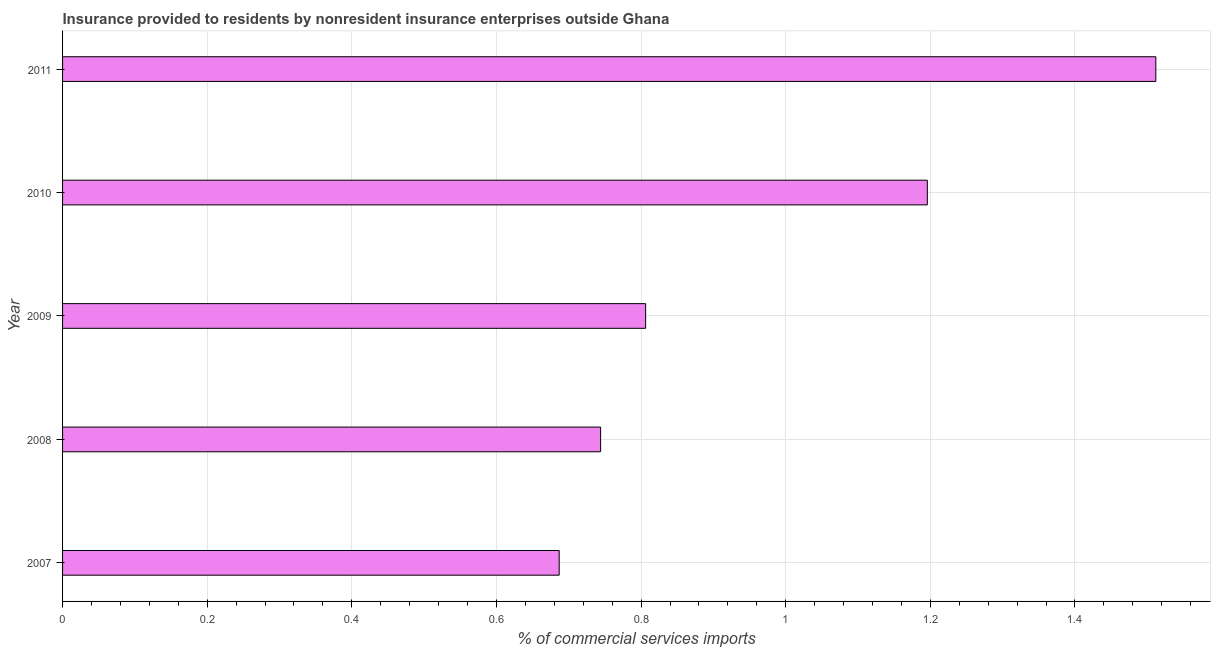Does the graph contain grids?
Offer a terse response. Yes. What is the title of the graph?
Provide a succinct answer. Insurance provided to residents by nonresident insurance enterprises outside Ghana. What is the label or title of the X-axis?
Give a very brief answer. % of commercial services imports. What is the insurance provided by non-residents in 2010?
Your answer should be very brief. 1.2. Across all years, what is the maximum insurance provided by non-residents?
Your answer should be very brief. 1.51. Across all years, what is the minimum insurance provided by non-residents?
Your answer should be very brief. 0.69. In which year was the insurance provided by non-residents maximum?
Offer a very short reply. 2011. What is the sum of the insurance provided by non-residents?
Offer a terse response. 4.94. What is the difference between the insurance provided by non-residents in 2007 and 2011?
Your answer should be very brief. -0.82. What is the average insurance provided by non-residents per year?
Give a very brief answer. 0.99. What is the median insurance provided by non-residents?
Give a very brief answer. 0.81. What is the ratio of the insurance provided by non-residents in 2009 to that in 2010?
Make the answer very short. 0.67. Is the difference between the insurance provided by non-residents in 2007 and 2008 greater than the difference between any two years?
Make the answer very short. No. What is the difference between the highest and the second highest insurance provided by non-residents?
Keep it short and to the point. 0.32. What is the difference between the highest and the lowest insurance provided by non-residents?
Your response must be concise. 0.83. In how many years, is the insurance provided by non-residents greater than the average insurance provided by non-residents taken over all years?
Offer a terse response. 2. Are all the bars in the graph horizontal?
Make the answer very short. Yes. How many years are there in the graph?
Make the answer very short. 5. Are the values on the major ticks of X-axis written in scientific E-notation?
Provide a short and direct response. No. What is the % of commercial services imports in 2007?
Your response must be concise. 0.69. What is the % of commercial services imports of 2008?
Ensure brevity in your answer.  0.74. What is the % of commercial services imports of 2009?
Your response must be concise. 0.81. What is the % of commercial services imports in 2010?
Offer a terse response. 1.2. What is the % of commercial services imports in 2011?
Your answer should be compact. 1.51. What is the difference between the % of commercial services imports in 2007 and 2008?
Offer a terse response. -0.06. What is the difference between the % of commercial services imports in 2007 and 2009?
Keep it short and to the point. -0.12. What is the difference between the % of commercial services imports in 2007 and 2010?
Give a very brief answer. -0.51. What is the difference between the % of commercial services imports in 2007 and 2011?
Your answer should be very brief. -0.83. What is the difference between the % of commercial services imports in 2008 and 2009?
Your response must be concise. -0.06. What is the difference between the % of commercial services imports in 2008 and 2010?
Keep it short and to the point. -0.45. What is the difference between the % of commercial services imports in 2008 and 2011?
Offer a very short reply. -0.77. What is the difference between the % of commercial services imports in 2009 and 2010?
Offer a very short reply. -0.39. What is the difference between the % of commercial services imports in 2009 and 2011?
Provide a succinct answer. -0.71. What is the difference between the % of commercial services imports in 2010 and 2011?
Provide a short and direct response. -0.32. What is the ratio of the % of commercial services imports in 2007 to that in 2008?
Make the answer very short. 0.92. What is the ratio of the % of commercial services imports in 2007 to that in 2009?
Your answer should be compact. 0.85. What is the ratio of the % of commercial services imports in 2007 to that in 2010?
Your response must be concise. 0.57. What is the ratio of the % of commercial services imports in 2007 to that in 2011?
Your answer should be compact. 0.45. What is the ratio of the % of commercial services imports in 2008 to that in 2009?
Make the answer very short. 0.92. What is the ratio of the % of commercial services imports in 2008 to that in 2010?
Offer a terse response. 0.62. What is the ratio of the % of commercial services imports in 2008 to that in 2011?
Your answer should be compact. 0.49. What is the ratio of the % of commercial services imports in 2009 to that in 2010?
Ensure brevity in your answer.  0.67. What is the ratio of the % of commercial services imports in 2009 to that in 2011?
Give a very brief answer. 0.53. What is the ratio of the % of commercial services imports in 2010 to that in 2011?
Your answer should be compact. 0.79. 